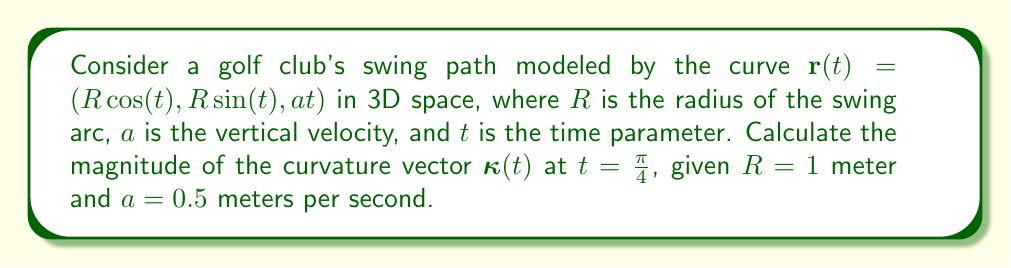Give your solution to this math problem. To analyze the curvature of the golf club's swing path, we'll follow these steps:

1) The curvature vector $\boldsymbol{\kappa}(t)$ is given by:

   $$\boldsymbol{\kappa}(t) = \frac{\mathbf{r}'(t) \times \mathbf{r}''(t)}{|\mathbf{r}'(t)|^3}$$

2) First, let's calculate $\mathbf{r}'(t)$ and $\mathbf{r}''(t)$:

   $$\mathbf{r}'(t) = (-R\sin(t), R\cos(t), a)$$
   $$\mathbf{r}''(t) = (-R\cos(t), -R\sin(t), 0)$$

3) Now, we compute the cross product $\mathbf{r}'(t) \times \mathbf{r}''(t)$:

   $$\mathbf{r}'(t) \times \mathbf{r}''(t) = (aR\sin(t), -aR\cos(t), R^2)$$

4) Calculate $|\mathbf{r}'(t)|$:

   $$|\mathbf{r}'(t)| = \sqrt{R^2\sin^2(t) + R^2\cos^2(t) + a^2} = \sqrt{R^2 + a^2}$$

5) Now we can form the curvature vector:

   $$\boldsymbol{\kappa}(t) = \frac{(aR\sin(t), -aR\cos(t), R^2)}{(R^2 + a^2)^{3/2}}$$

6) The magnitude of the curvature vector is:

   $$|\boldsymbol{\kappa}(t)| = \frac{\sqrt{a^2R^2\sin^2(t) + a^2R^2\cos^2(t) + R^4}}{(R^2 + a^2)^{3/2}} = \frac{\sqrt{a^2R^2 + R^4}}{(R^2 + a^2)^{3/2}}$$

7) Substituting the given values ($R=1$, $a=0.5$, $t=\frac{\pi}{4}$):

   $$|\boldsymbol{\kappa}(\frac{\pi}{4})| = \frac{\sqrt{(0.5)^2(1)^2 + (1)^4}}{((1)^2 + (0.5)^2)^{3/2}} = \frac{\sqrt{1.25}}{(1.25)^{3/2}} = \frac{\sqrt{1.25}}{1.25\sqrt{1.25}} = \frac{1}{1.25} = 0.8$$

Thus, the magnitude of the curvature vector at $t=\frac{\pi}{4}$ is 0.8 m^(-1).
Answer: 0.8 m^(-1) 